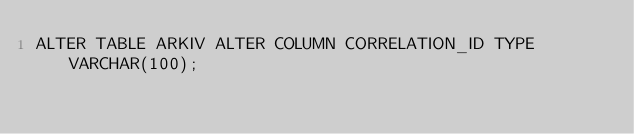Convert code to text. <code><loc_0><loc_0><loc_500><loc_500><_SQL_>ALTER TABLE ARKIV ALTER COLUMN CORRELATION_ID TYPE VARCHAR(100);</code> 